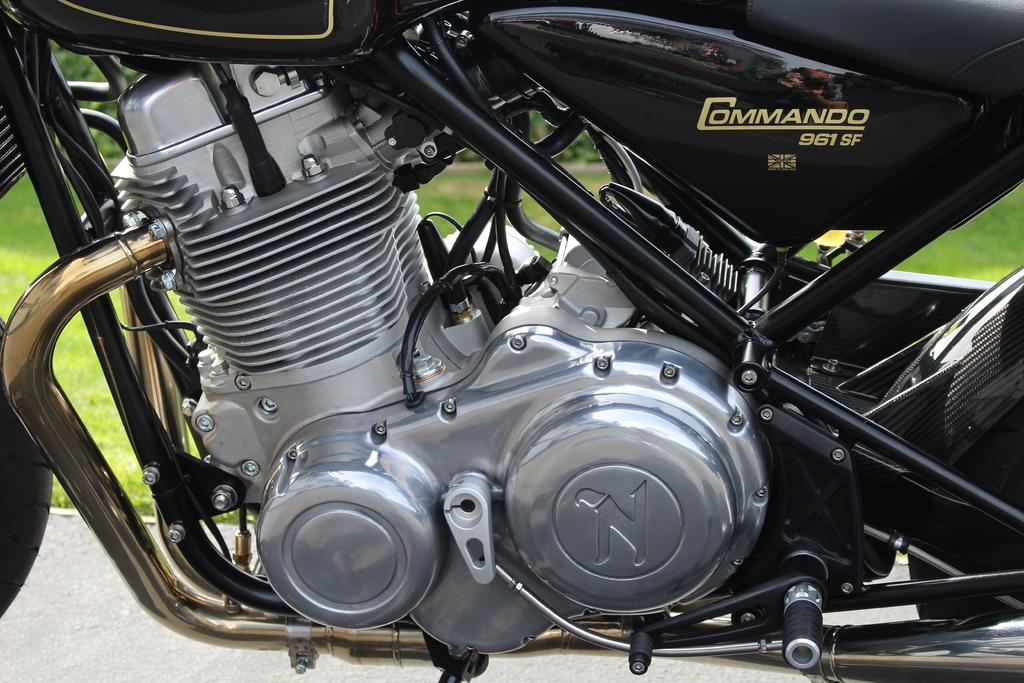What is on the road in the image? There is a bike on the road in the image. What type of vegetation can be seen in the image? There is grass visible in the image, and there are also trees. Can you tell if the image was taken during the day or night? The image was likely taken during the day, as there is no indication of darkness or artificial lighting. What type of cushion is being used by the pets in the image? There are no pets or cushions present in the image. 